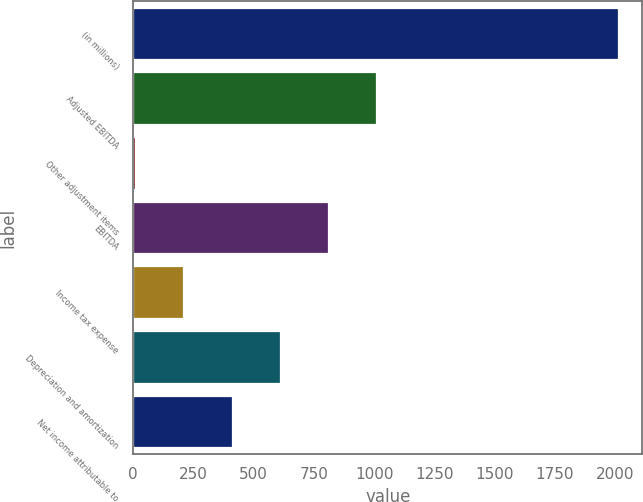<chart> <loc_0><loc_0><loc_500><loc_500><bar_chart><fcel>(in millions)<fcel>Adjusted EBITDA<fcel>Other adjustment items<fcel>EBITDA<fcel>Income tax expense<fcel>Depreciation and amortization<fcel>Net income attributable to<nl><fcel>2012<fcel>1009.5<fcel>7<fcel>809<fcel>207.5<fcel>608.5<fcel>408<nl></chart> 